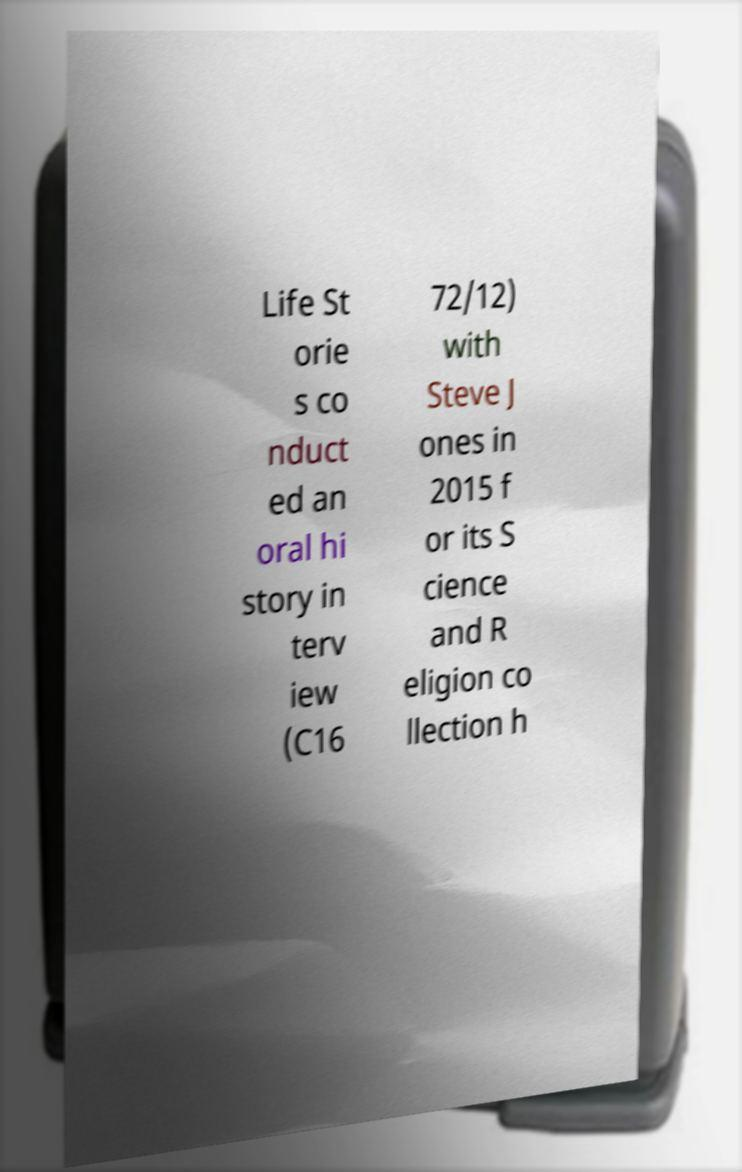Can you accurately transcribe the text from the provided image for me? Life St orie s co nduct ed an oral hi story in terv iew (C16 72/12) with Steve J ones in 2015 f or its S cience and R eligion co llection h 